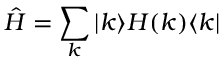<formula> <loc_0><loc_0><loc_500><loc_500>\hat { H } = \sum _ { k } | k \rangle H ( k ) \langle k |</formula> 